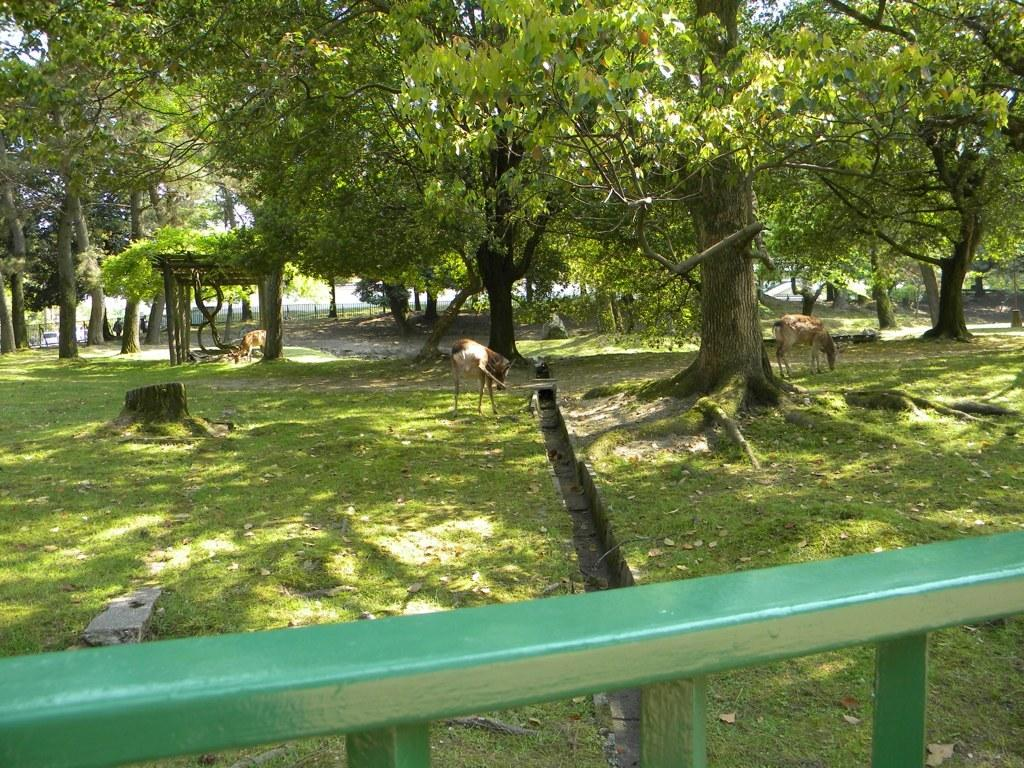What type of vegetation can be seen in the image? There are trees in the image. What is located under the trees? Animals are present under the trees. What color is the rod at the bottom of the image? There is a green color rod at the bottom of the image. What type of flesh can be seen on the animals in the image? There is no flesh visible on the animals in the image; the image does not show any close-up or detailed view of the animals. 